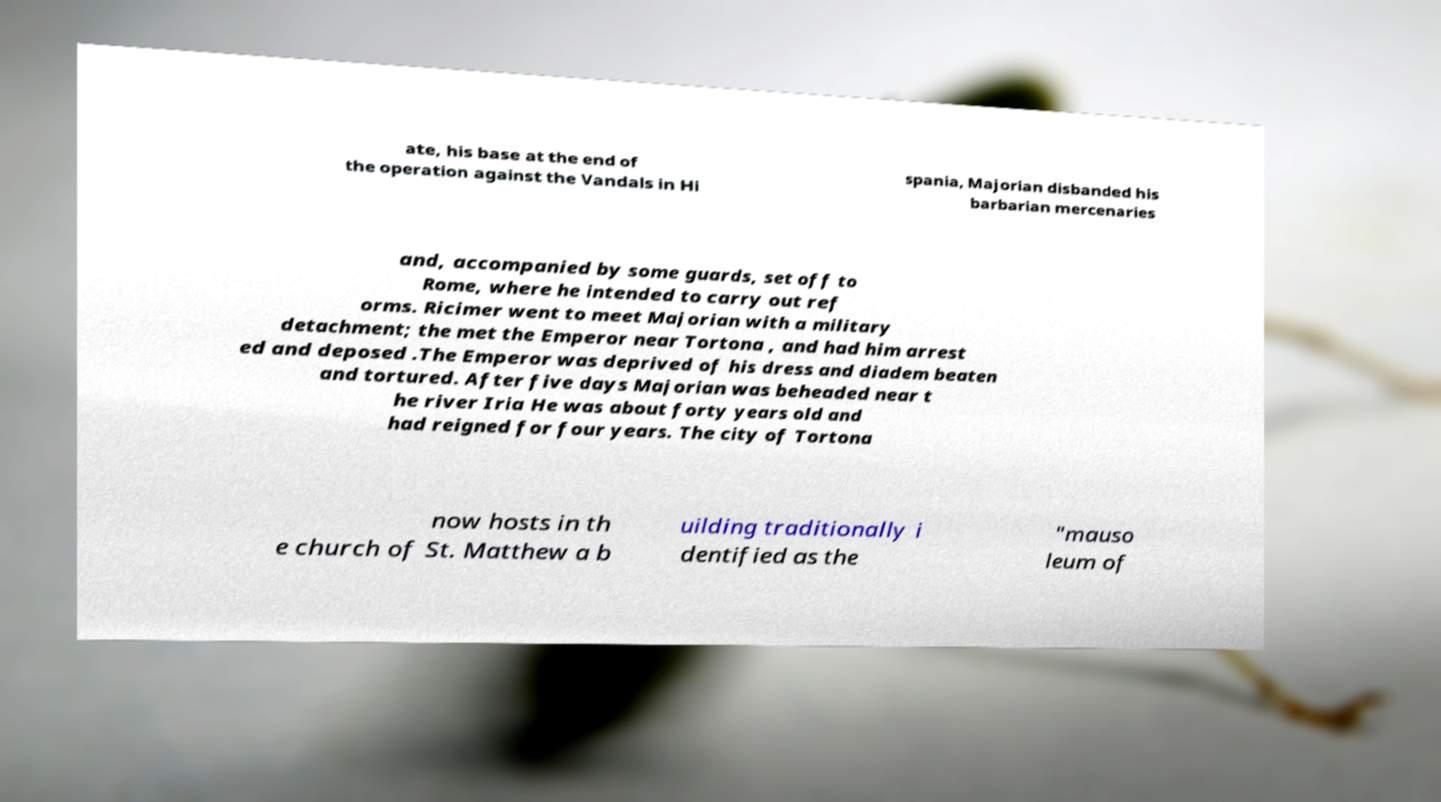Can you read and provide the text displayed in the image?This photo seems to have some interesting text. Can you extract and type it out for me? ate, his base at the end of the operation against the Vandals in Hi spania, Majorian disbanded his barbarian mercenaries and, accompanied by some guards, set off to Rome, where he intended to carry out ref orms. Ricimer went to meet Majorian with a military detachment; the met the Emperor near Tortona , and had him arrest ed and deposed .The Emperor was deprived of his dress and diadem beaten and tortured. After five days Majorian was beheaded near t he river Iria He was about forty years old and had reigned for four years. The city of Tortona now hosts in th e church of St. Matthew a b uilding traditionally i dentified as the "mauso leum of 